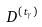Convert formula to latex. <formula><loc_0><loc_0><loc_500><loc_500>D ^ { ( t _ { \gamma } ) }</formula> 